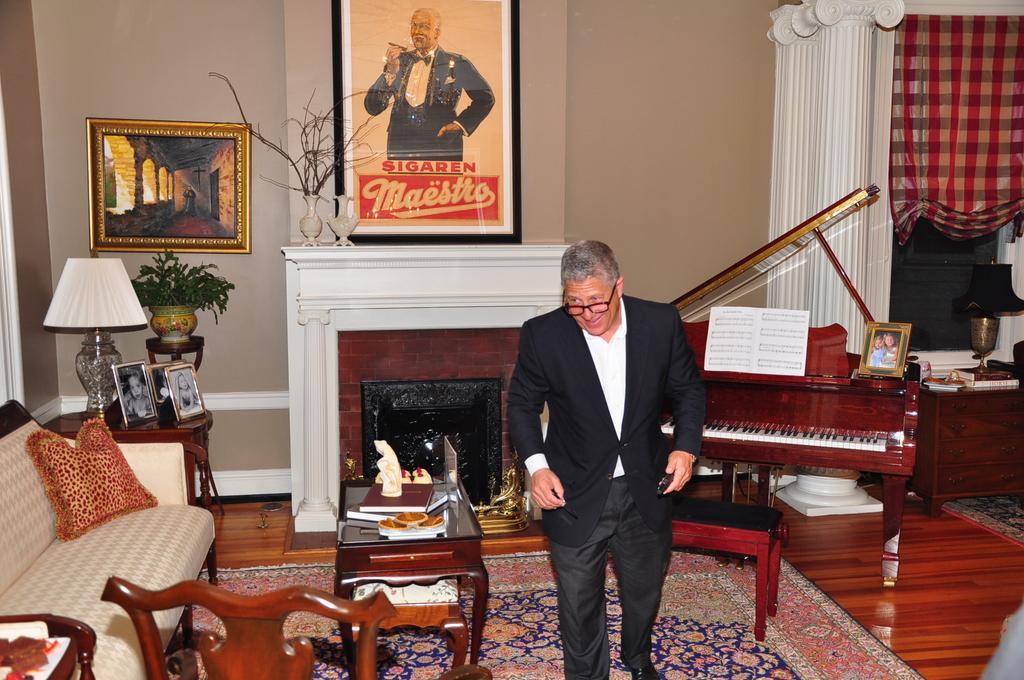How would you summarize this image in a sentence or two? The image is taken in the room. In the center of the image there is a man standing. On the left there is a sofa. On the right there is a piano. In the center there is a table and books placed on the table. In the background there is a stand and some frames placed on the table. In the background there are photo frames which are attached to the wall and there is a curtain. 